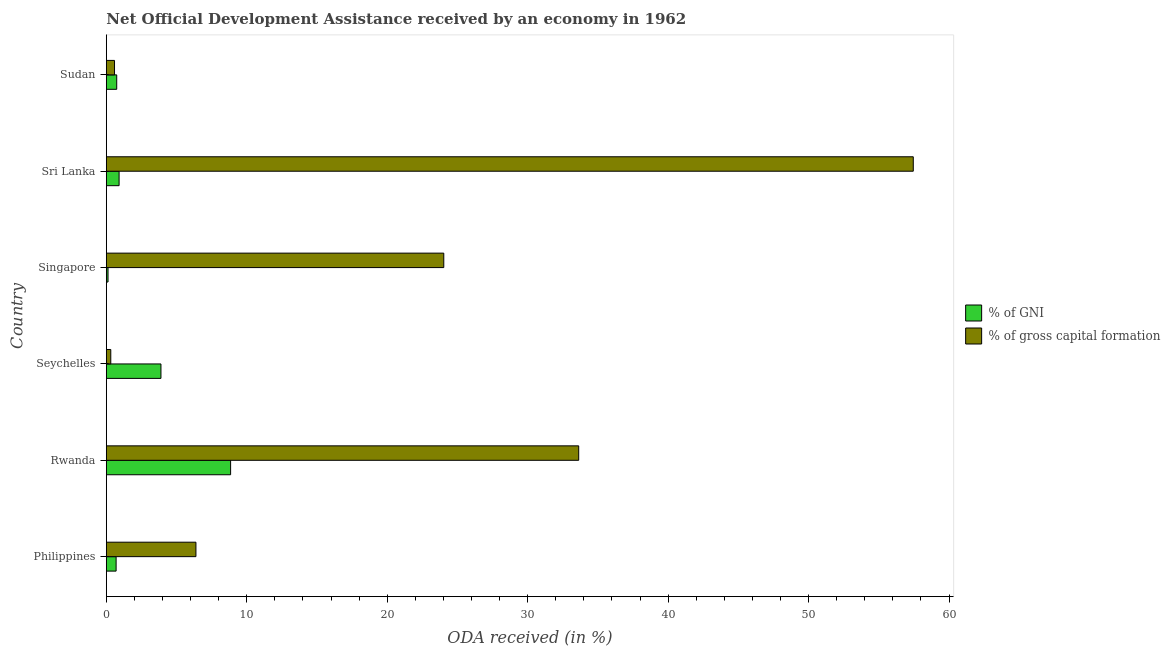How many different coloured bars are there?
Offer a very short reply. 2. Are the number of bars per tick equal to the number of legend labels?
Make the answer very short. Yes. Are the number of bars on each tick of the Y-axis equal?
Offer a very short reply. Yes. How many bars are there on the 1st tick from the top?
Your answer should be very brief. 2. How many bars are there on the 4th tick from the bottom?
Provide a short and direct response. 2. What is the label of the 5th group of bars from the top?
Your response must be concise. Rwanda. In how many cases, is the number of bars for a given country not equal to the number of legend labels?
Provide a short and direct response. 0. What is the oda received as percentage of gni in Sri Lanka?
Offer a very short reply. 0.91. Across all countries, what is the maximum oda received as percentage of gni?
Provide a short and direct response. 8.85. Across all countries, what is the minimum oda received as percentage of gross capital formation?
Give a very brief answer. 0.32. In which country was the oda received as percentage of gross capital formation maximum?
Offer a very short reply. Sri Lanka. In which country was the oda received as percentage of gross capital formation minimum?
Your answer should be very brief. Seychelles. What is the total oda received as percentage of gni in the graph?
Keep it short and to the point. 15.2. What is the difference between the oda received as percentage of gni in Rwanda and that in Sri Lanka?
Your response must be concise. 7.94. What is the difference between the oda received as percentage of gni in Singapore and the oda received as percentage of gross capital formation in Rwanda?
Provide a short and direct response. -33.51. What is the average oda received as percentage of gni per country?
Provide a short and direct response. 2.53. What is the difference between the oda received as percentage of gross capital formation and oda received as percentage of gni in Seychelles?
Provide a short and direct response. -3.57. What is the ratio of the oda received as percentage of gni in Rwanda to that in Singapore?
Keep it short and to the point. 73.04. What is the difference between the highest and the second highest oda received as percentage of gross capital formation?
Provide a short and direct response. 23.82. What is the difference between the highest and the lowest oda received as percentage of gross capital formation?
Make the answer very short. 57.14. What does the 1st bar from the top in Seychelles represents?
Provide a succinct answer. % of gross capital formation. What does the 1st bar from the bottom in Seychelles represents?
Offer a very short reply. % of GNI. How many countries are there in the graph?
Provide a short and direct response. 6. Does the graph contain any zero values?
Ensure brevity in your answer.  No. Where does the legend appear in the graph?
Make the answer very short. Center right. What is the title of the graph?
Your answer should be very brief. Net Official Development Assistance received by an economy in 1962. Does "Travel Items" appear as one of the legend labels in the graph?
Give a very brief answer. No. What is the label or title of the X-axis?
Make the answer very short. ODA received (in %). What is the ODA received (in %) in % of GNI in Philippines?
Your answer should be compact. 0.7. What is the ODA received (in %) of % of gross capital formation in Philippines?
Provide a short and direct response. 6.38. What is the ODA received (in %) of % of GNI in Rwanda?
Provide a short and direct response. 8.85. What is the ODA received (in %) in % of gross capital formation in Rwanda?
Keep it short and to the point. 33.63. What is the ODA received (in %) of % of GNI in Seychelles?
Give a very brief answer. 3.89. What is the ODA received (in %) in % of gross capital formation in Seychelles?
Your answer should be compact. 0.32. What is the ODA received (in %) of % of GNI in Singapore?
Keep it short and to the point. 0.12. What is the ODA received (in %) of % of gross capital formation in Singapore?
Offer a very short reply. 24.03. What is the ODA received (in %) of % of GNI in Sri Lanka?
Provide a succinct answer. 0.91. What is the ODA received (in %) in % of gross capital formation in Sri Lanka?
Ensure brevity in your answer.  57.46. What is the ODA received (in %) in % of GNI in Sudan?
Your answer should be very brief. 0.74. What is the ODA received (in %) of % of gross capital formation in Sudan?
Your answer should be compact. 0.58. Across all countries, what is the maximum ODA received (in %) of % of GNI?
Your answer should be very brief. 8.85. Across all countries, what is the maximum ODA received (in %) in % of gross capital formation?
Give a very brief answer. 57.46. Across all countries, what is the minimum ODA received (in %) in % of GNI?
Make the answer very short. 0.12. Across all countries, what is the minimum ODA received (in %) in % of gross capital formation?
Provide a succinct answer. 0.32. What is the total ODA received (in %) of % of GNI in the graph?
Offer a terse response. 15.2. What is the total ODA received (in %) in % of gross capital formation in the graph?
Your answer should be compact. 122.4. What is the difference between the ODA received (in %) in % of GNI in Philippines and that in Rwanda?
Your response must be concise. -8.15. What is the difference between the ODA received (in %) in % of gross capital formation in Philippines and that in Rwanda?
Your response must be concise. -27.25. What is the difference between the ODA received (in %) in % of GNI in Philippines and that in Seychelles?
Give a very brief answer. -3.19. What is the difference between the ODA received (in %) in % of gross capital formation in Philippines and that in Seychelles?
Give a very brief answer. 6.06. What is the difference between the ODA received (in %) in % of GNI in Philippines and that in Singapore?
Your answer should be compact. 0.57. What is the difference between the ODA received (in %) of % of gross capital formation in Philippines and that in Singapore?
Your response must be concise. -17.65. What is the difference between the ODA received (in %) in % of GNI in Philippines and that in Sri Lanka?
Keep it short and to the point. -0.21. What is the difference between the ODA received (in %) in % of gross capital formation in Philippines and that in Sri Lanka?
Ensure brevity in your answer.  -51.08. What is the difference between the ODA received (in %) of % of GNI in Philippines and that in Sudan?
Your answer should be very brief. -0.04. What is the difference between the ODA received (in %) in % of gross capital formation in Philippines and that in Sudan?
Offer a terse response. 5.8. What is the difference between the ODA received (in %) in % of GNI in Rwanda and that in Seychelles?
Provide a succinct answer. 4.96. What is the difference between the ODA received (in %) in % of gross capital formation in Rwanda and that in Seychelles?
Provide a succinct answer. 33.32. What is the difference between the ODA received (in %) of % of GNI in Rwanda and that in Singapore?
Offer a very short reply. 8.73. What is the difference between the ODA received (in %) in % of gross capital formation in Rwanda and that in Singapore?
Your answer should be very brief. 9.61. What is the difference between the ODA received (in %) in % of GNI in Rwanda and that in Sri Lanka?
Your answer should be compact. 7.94. What is the difference between the ODA received (in %) of % of gross capital formation in Rwanda and that in Sri Lanka?
Offer a terse response. -23.82. What is the difference between the ODA received (in %) of % of GNI in Rwanda and that in Sudan?
Offer a terse response. 8.11. What is the difference between the ODA received (in %) of % of gross capital formation in Rwanda and that in Sudan?
Offer a very short reply. 33.05. What is the difference between the ODA received (in %) of % of GNI in Seychelles and that in Singapore?
Make the answer very short. 3.77. What is the difference between the ODA received (in %) in % of gross capital formation in Seychelles and that in Singapore?
Your answer should be compact. -23.71. What is the difference between the ODA received (in %) in % of GNI in Seychelles and that in Sri Lanka?
Your answer should be very brief. 2.98. What is the difference between the ODA received (in %) of % of gross capital formation in Seychelles and that in Sri Lanka?
Provide a short and direct response. -57.14. What is the difference between the ODA received (in %) in % of GNI in Seychelles and that in Sudan?
Provide a short and direct response. 3.15. What is the difference between the ODA received (in %) of % of gross capital formation in Seychelles and that in Sudan?
Give a very brief answer. -0.27. What is the difference between the ODA received (in %) in % of GNI in Singapore and that in Sri Lanka?
Provide a short and direct response. -0.79. What is the difference between the ODA received (in %) in % of gross capital formation in Singapore and that in Sri Lanka?
Make the answer very short. -33.43. What is the difference between the ODA received (in %) in % of GNI in Singapore and that in Sudan?
Your response must be concise. -0.62. What is the difference between the ODA received (in %) in % of gross capital formation in Singapore and that in Sudan?
Your answer should be very brief. 23.44. What is the difference between the ODA received (in %) of % of GNI in Sri Lanka and that in Sudan?
Ensure brevity in your answer.  0.17. What is the difference between the ODA received (in %) of % of gross capital formation in Sri Lanka and that in Sudan?
Offer a terse response. 56.87. What is the difference between the ODA received (in %) of % of GNI in Philippines and the ODA received (in %) of % of gross capital formation in Rwanda?
Make the answer very short. -32.94. What is the difference between the ODA received (in %) in % of GNI in Philippines and the ODA received (in %) in % of gross capital formation in Seychelles?
Your answer should be very brief. 0.38. What is the difference between the ODA received (in %) in % of GNI in Philippines and the ODA received (in %) in % of gross capital formation in Singapore?
Your answer should be compact. -23.33. What is the difference between the ODA received (in %) in % of GNI in Philippines and the ODA received (in %) in % of gross capital formation in Sri Lanka?
Give a very brief answer. -56.76. What is the difference between the ODA received (in %) in % of GNI in Philippines and the ODA received (in %) in % of gross capital formation in Sudan?
Ensure brevity in your answer.  0.11. What is the difference between the ODA received (in %) of % of GNI in Rwanda and the ODA received (in %) of % of gross capital formation in Seychelles?
Give a very brief answer. 8.53. What is the difference between the ODA received (in %) in % of GNI in Rwanda and the ODA received (in %) in % of gross capital formation in Singapore?
Offer a very short reply. -15.18. What is the difference between the ODA received (in %) of % of GNI in Rwanda and the ODA received (in %) of % of gross capital formation in Sri Lanka?
Offer a very short reply. -48.61. What is the difference between the ODA received (in %) of % of GNI in Rwanda and the ODA received (in %) of % of gross capital formation in Sudan?
Provide a succinct answer. 8.27. What is the difference between the ODA received (in %) in % of GNI in Seychelles and the ODA received (in %) in % of gross capital formation in Singapore?
Your answer should be very brief. -20.14. What is the difference between the ODA received (in %) in % of GNI in Seychelles and the ODA received (in %) in % of gross capital formation in Sri Lanka?
Provide a succinct answer. -53.57. What is the difference between the ODA received (in %) of % of GNI in Seychelles and the ODA received (in %) of % of gross capital formation in Sudan?
Give a very brief answer. 3.31. What is the difference between the ODA received (in %) in % of GNI in Singapore and the ODA received (in %) in % of gross capital formation in Sri Lanka?
Your response must be concise. -57.34. What is the difference between the ODA received (in %) of % of GNI in Singapore and the ODA received (in %) of % of gross capital formation in Sudan?
Make the answer very short. -0.46. What is the difference between the ODA received (in %) in % of GNI in Sri Lanka and the ODA received (in %) in % of gross capital formation in Sudan?
Ensure brevity in your answer.  0.33. What is the average ODA received (in %) of % of GNI per country?
Provide a succinct answer. 2.53. What is the average ODA received (in %) in % of gross capital formation per country?
Your answer should be very brief. 20.4. What is the difference between the ODA received (in %) of % of GNI and ODA received (in %) of % of gross capital formation in Philippines?
Your response must be concise. -5.68. What is the difference between the ODA received (in %) in % of GNI and ODA received (in %) in % of gross capital formation in Rwanda?
Ensure brevity in your answer.  -24.78. What is the difference between the ODA received (in %) of % of GNI and ODA received (in %) of % of gross capital formation in Seychelles?
Make the answer very short. 3.57. What is the difference between the ODA received (in %) in % of GNI and ODA received (in %) in % of gross capital formation in Singapore?
Make the answer very short. -23.91. What is the difference between the ODA received (in %) of % of GNI and ODA received (in %) of % of gross capital formation in Sri Lanka?
Keep it short and to the point. -56.55. What is the difference between the ODA received (in %) of % of GNI and ODA received (in %) of % of gross capital formation in Sudan?
Your answer should be very brief. 0.16. What is the ratio of the ODA received (in %) of % of GNI in Philippines to that in Rwanda?
Provide a short and direct response. 0.08. What is the ratio of the ODA received (in %) of % of gross capital formation in Philippines to that in Rwanda?
Provide a succinct answer. 0.19. What is the ratio of the ODA received (in %) of % of GNI in Philippines to that in Seychelles?
Your response must be concise. 0.18. What is the ratio of the ODA received (in %) in % of gross capital formation in Philippines to that in Seychelles?
Give a very brief answer. 20.18. What is the ratio of the ODA received (in %) of % of GNI in Philippines to that in Singapore?
Give a very brief answer. 5.74. What is the ratio of the ODA received (in %) of % of gross capital formation in Philippines to that in Singapore?
Offer a terse response. 0.27. What is the ratio of the ODA received (in %) in % of GNI in Philippines to that in Sri Lanka?
Provide a succinct answer. 0.77. What is the ratio of the ODA received (in %) in % of gross capital formation in Philippines to that in Sri Lanka?
Give a very brief answer. 0.11. What is the ratio of the ODA received (in %) in % of GNI in Philippines to that in Sudan?
Keep it short and to the point. 0.94. What is the ratio of the ODA received (in %) of % of gross capital formation in Philippines to that in Sudan?
Your response must be concise. 10.96. What is the ratio of the ODA received (in %) of % of GNI in Rwanda to that in Seychelles?
Your answer should be compact. 2.28. What is the ratio of the ODA received (in %) of % of gross capital formation in Rwanda to that in Seychelles?
Offer a terse response. 106.37. What is the ratio of the ODA received (in %) in % of GNI in Rwanda to that in Singapore?
Your answer should be compact. 73.04. What is the ratio of the ODA received (in %) in % of gross capital formation in Rwanda to that in Singapore?
Your answer should be very brief. 1.4. What is the ratio of the ODA received (in %) in % of GNI in Rwanda to that in Sri Lanka?
Give a very brief answer. 9.73. What is the ratio of the ODA received (in %) in % of gross capital formation in Rwanda to that in Sri Lanka?
Your response must be concise. 0.59. What is the ratio of the ODA received (in %) in % of GNI in Rwanda to that in Sudan?
Your answer should be very brief. 11.96. What is the ratio of the ODA received (in %) in % of gross capital formation in Rwanda to that in Sudan?
Offer a terse response. 57.77. What is the ratio of the ODA received (in %) of % of GNI in Seychelles to that in Singapore?
Provide a succinct answer. 32.1. What is the ratio of the ODA received (in %) of % of gross capital formation in Seychelles to that in Singapore?
Your response must be concise. 0.01. What is the ratio of the ODA received (in %) in % of GNI in Seychelles to that in Sri Lanka?
Offer a very short reply. 4.28. What is the ratio of the ODA received (in %) in % of gross capital formation in Seychelles to that in Sri Lanka?
Provide a short and direct response. 0.01. What is the ratio of the ODA received (in %) in % of GNI in Seychelles to that in Sudan?
Offer a terse response. 5.26. What is the ratio of the ODA received (in %) in % of gross capital formation in Seychelles to that in Sudan?
Make the answer very short. 0.54. What is the ratio of the ODA received (in %) of % of GNI in Singapore to that in Sri Lanka?
Offer a very short reply. 0.13. What is the ratio of the ODA received (in %) in % of gross capital formation in Singapore to that in Sri Lanka?
Ensure brevity in your answer.  0.42. What is the ratio of the ODA received (in %) of % of GNI in Singapore to that in Sudan?
Provide a succinct answer. 0.16. What is the ratio of the ODA received (in %) of % of gross capital formation in Singapore to that in Sudan?
Offer a very short reply. 41.27. What is the ratio of the ODA received (in %) of % of GNI in Sri Lanka to that in Sudan?
Your answer should be compact. 1.23. What is the ratio of the ODA received (in %) in % of gross capital formation in Sri Lanka to that in Sudan?
Provide a succinct answer. 98.69. What is the difference between the highest and the second highest ODA received (in %) in % of GNI?
Your answer should be compact. 4.96. What is the difference between the highest and the second highest ODA received (in %) in % of gross capital formation?
Provide a succinct answer. 23.82. What is the difference between the highest and the lowest ODA received (in %) of % of GNI?
Ensure brevity in your answer.  8.73. What is the difference between the highest and the lowest ODA received (in %) of % of gross capital formation?
Ensure brevity in your answer.  57.14. 